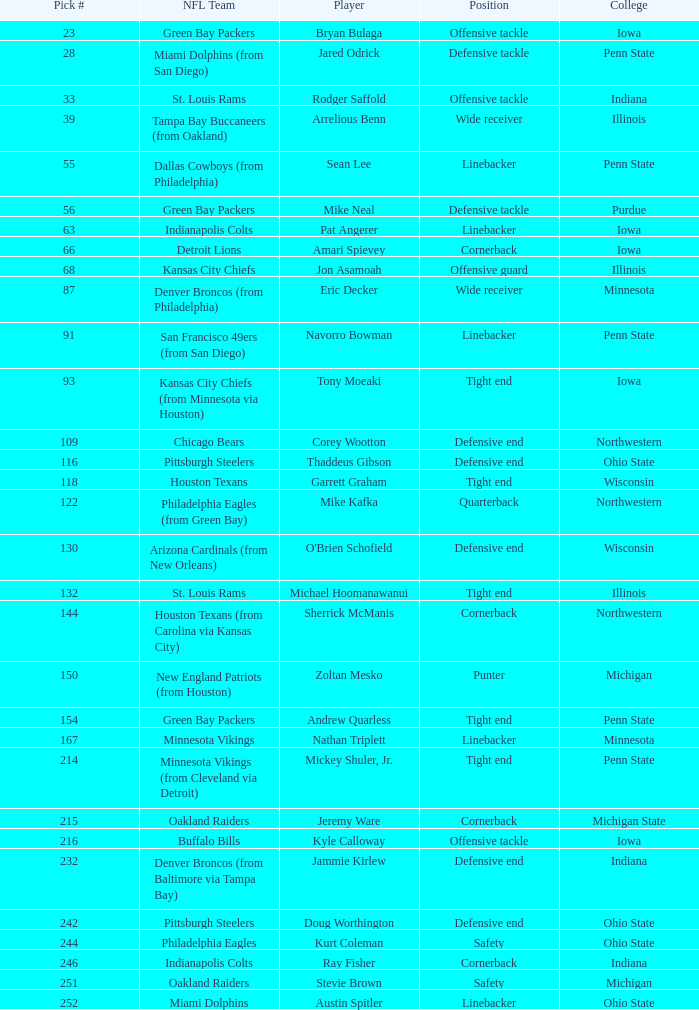What NFL team was the player with pick number 28 drafted to? Miami Dolphins (from San Diego). 